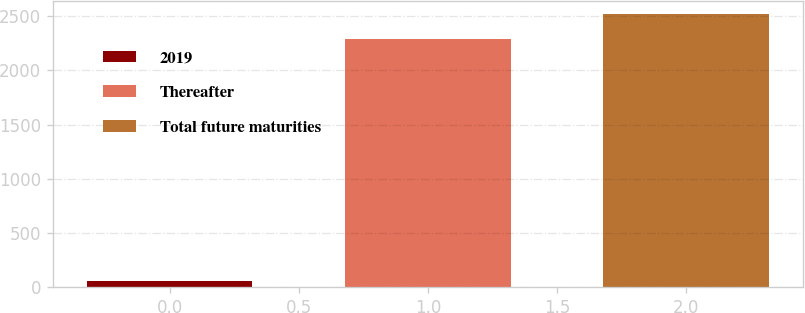<chart> <loc_0><loc_0><loc_500><loc_500><bar_chart><fcel>2019<fcel>Thereafter<fcel>Total future maturities<nl><fcel>54<fcel>2288<fcel>2516.8<nl></chart> 